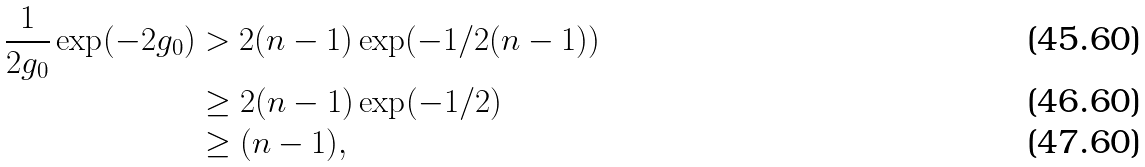<formula> <loc_0><loc_0><loc_500><loc_500>\frac { 1 } { 2 g _ { 0 } } \exp ( - 2 g _ { 0 } ) & > 2 ( n - 1 ) \exp ( - 1 / 2 ( n - 1 ) ) \\ & \geq 2 ( n - 1 ) \exp ( - 1 / 2 ) \\ & \geq ( n - 1 ) ,</formula> 